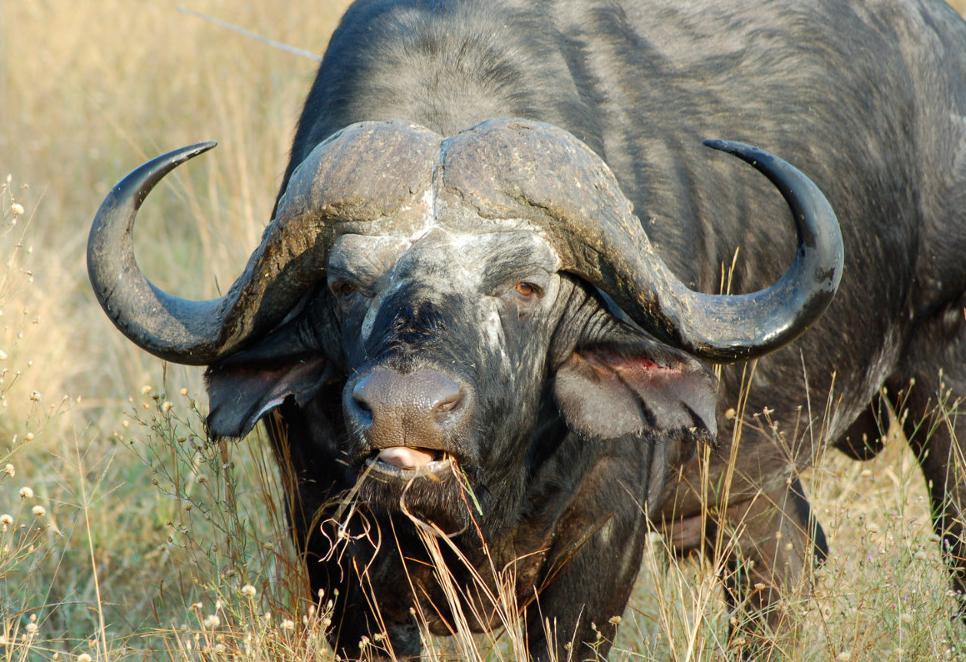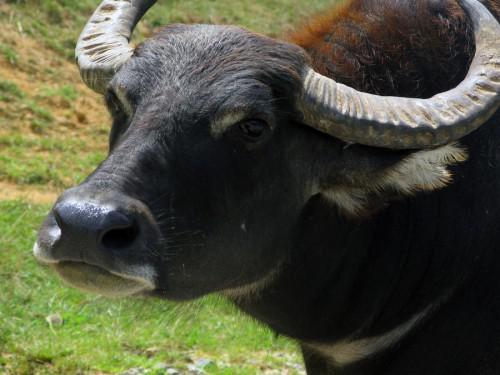The first image is the image on the left, the second image is the image on the right. Analyze the images presented: Is the assertion "Left image shows one forward-facing water buffalo standing on dry ground." valid? Answer yes or no. Yes. The first image is the image on the left, the second image is the image on the right. For the images shown, is this caption "None of the animals are near the water." true? Answer yes or no. Yes. 